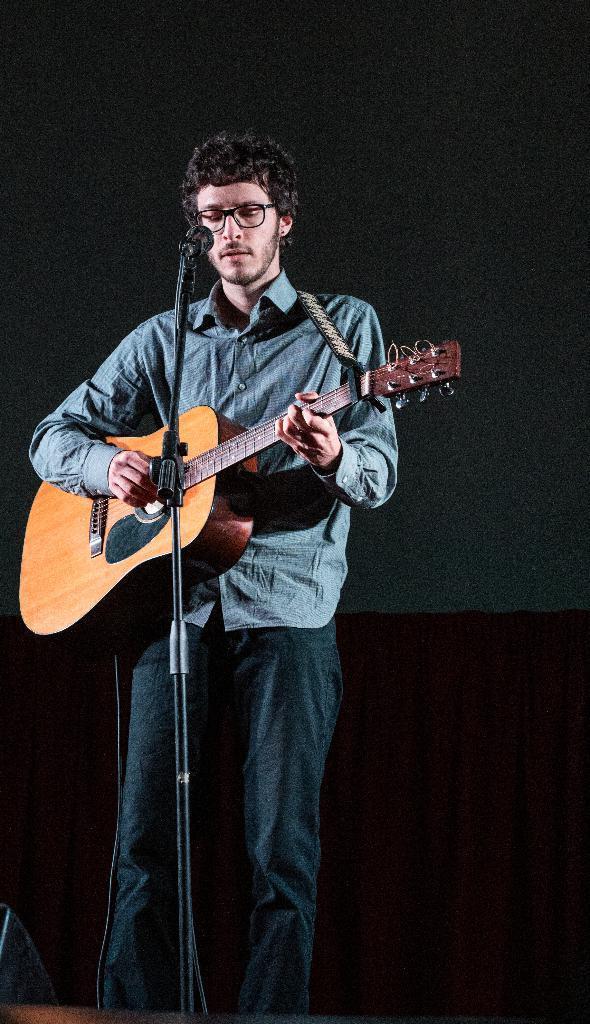How would you summarize this image in a sentence or two? In the picture we can see a person holding a guitar and singing a song in a micro phone which is in front of him. 